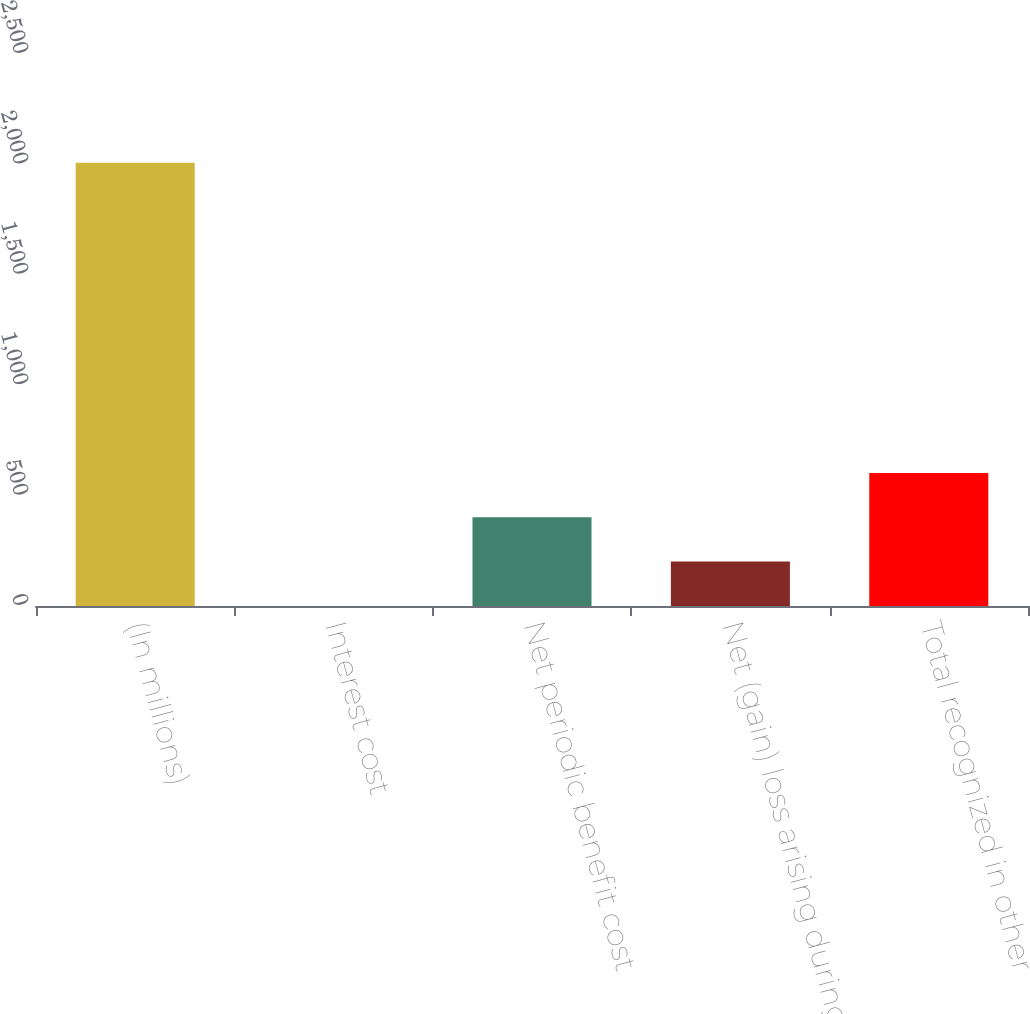Convert chart to OTSL. <chart><loc_0><loc_0><loc_500><loc_500><bar_chart><fcel>(In millions)<fcel>Interest cost<fcel>Net periodic benefit cost<fcel>Net (gain) loss arising during<fcel>Total recognized in other<nl><fcel>2008<fcel>0.4<fcel>401.92<fcel>201.16<fcel>602.68<nl></chart> 